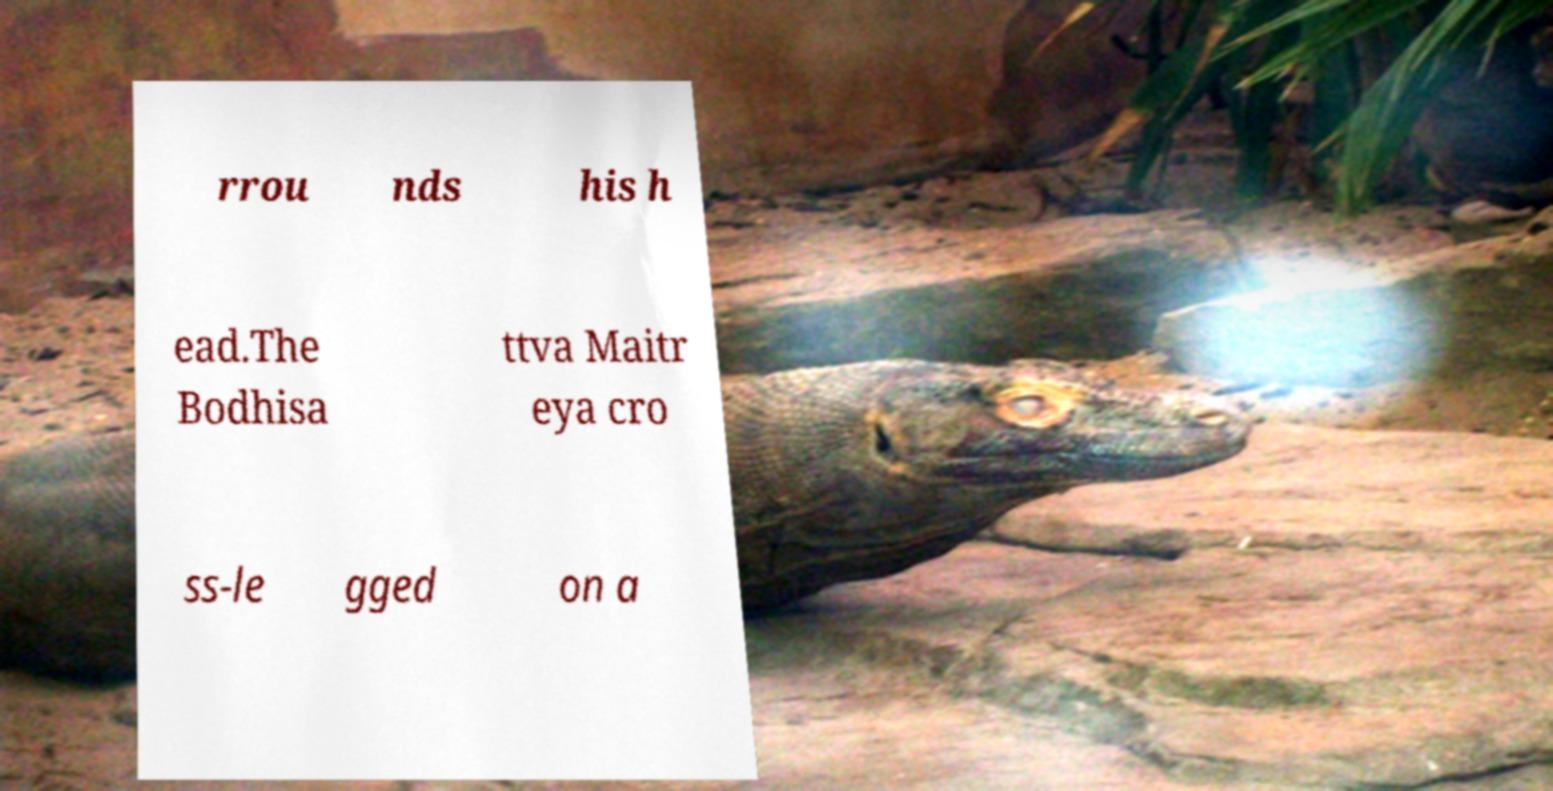Please read and relay the text visible in this image. What does it say? rrou nds his h ead.The Bodhisa ttva Maitr eya cro ss-le gged on a 